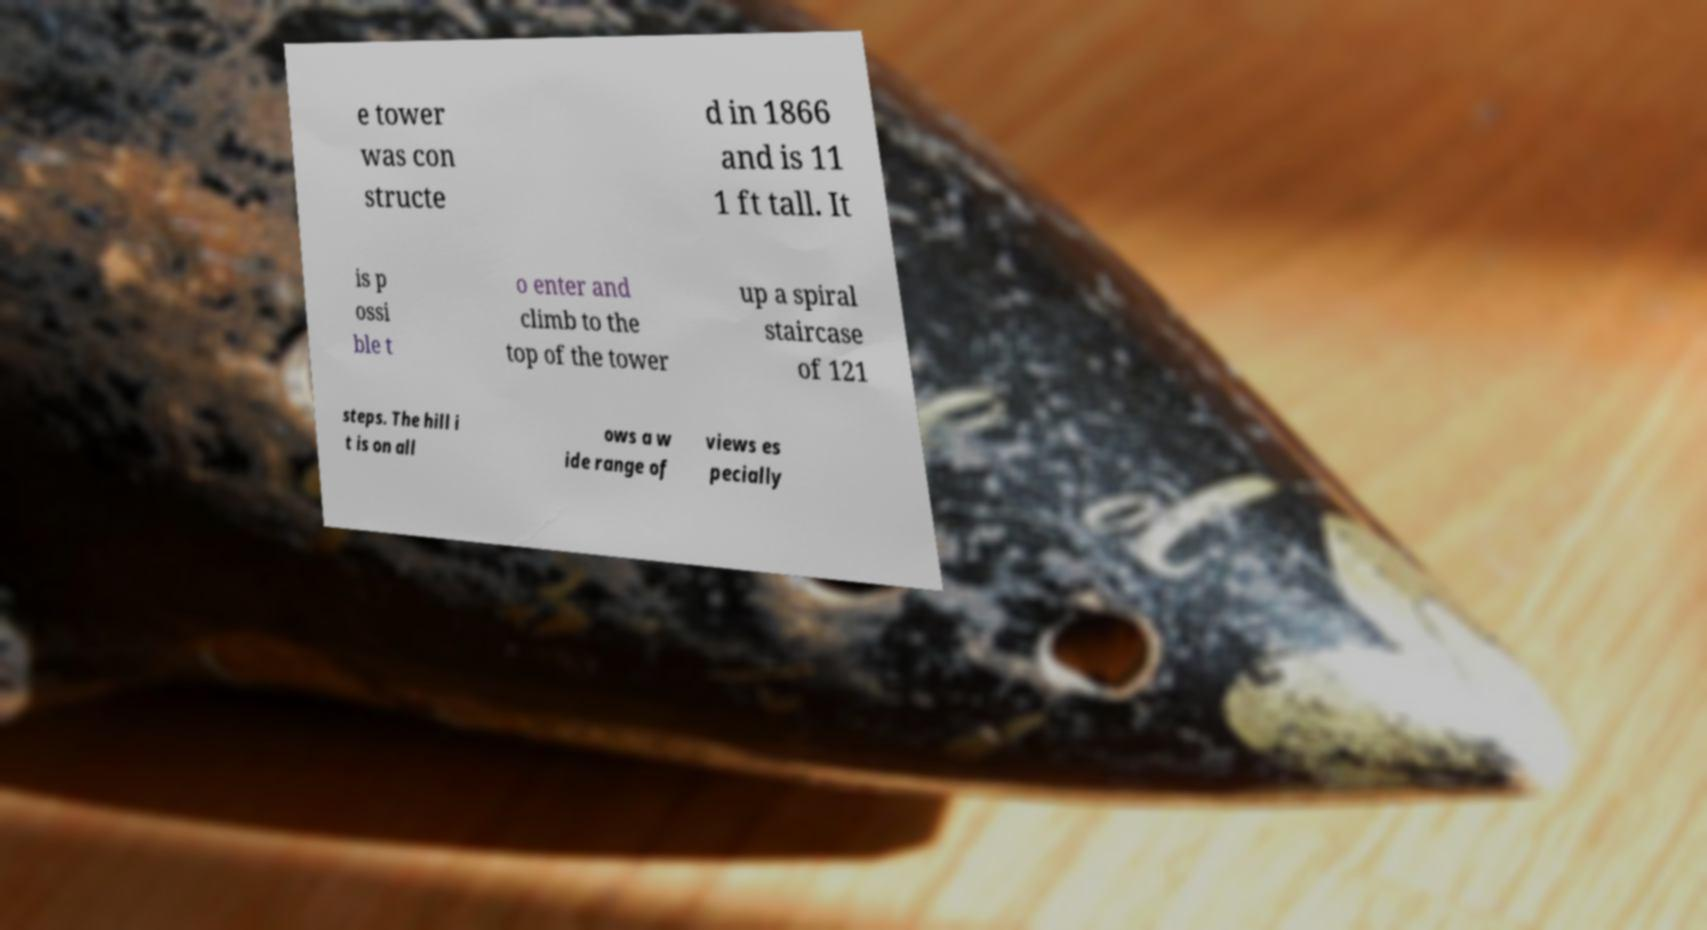Could you assist in decoding the text presented in this image and type it out clearly? e tower was con structe d in 1866 and is 11 1 ft tall. It is p ossi ble t o enter and climb to the top of the tower up a spiral staircase of 121 steps. The hill i t is on all ows a w ide range of views es pecially 